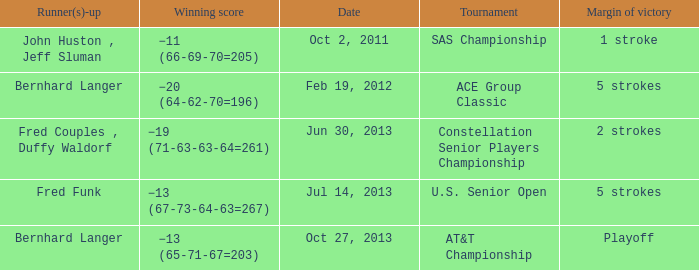Who's the Runner(s)-up with a Winning score of −19 (71-63-63-64=261)? Fred Couples , Duffy Waldorf. 